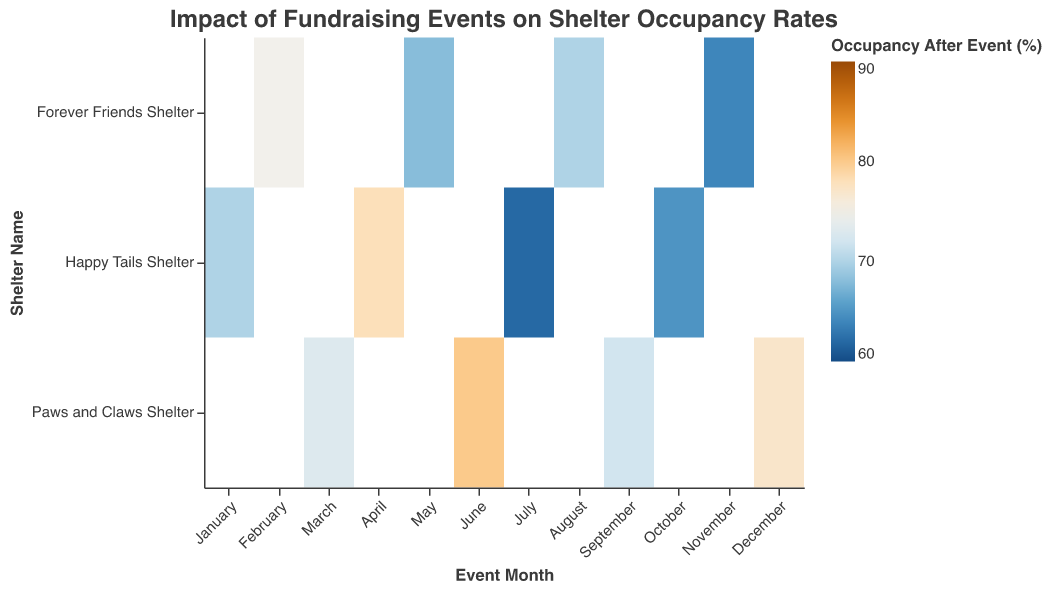What is the title of the figure? The title of the figure is displayed at the top of the heatmap. It is usually in a large font size and describes the main topic of the plot.
Answer: Impact of Fundraising Events on Shelter Occupancy Rates What are the axis labels in the heatmap? The axis labels describe what each axis represents. The x-axis is labeled "Event Month," and the y-axis is labeled "Shelter Name."
Answer: Event Month, Shelter Name Which event had the highest donation amount? By looking at the "Donation Amount (USD)" in the tooltip of each cell, the highest donation amount can be identified.
Answer: Gala Dinner in May Which shelter had the largest decrease in occupancy rate after an event? By comparing the "Occupancy Before Event (%)" and "Occupancy After Event (%)" values in each cell, the largest decrease can be identified. The largest decrease is for "Happy Tails Shelter" in July (88% - 62% = 26%).
Answer: Happy Tails Shelter in July What is the average post-event occupancy rate for Happy Tails Shelter? Adding the "Occupancy After Event (%)" values for Happy Tails Shelter's events and dividing by the number of events: (70 + 78 + 62 + 65) / 4 = 68.75%.
Answer: 68.75% Which event type appears most frequently in the heatmap? Counting the occurrences of each "Event Type" in the tooltip reveals that there are multiple events types, but several types have the same frequency. For example, "Auction" appears twice.
Answer: Auction Which month had the highest number of animals adopted? Summing the "Animals Adopted" for each event in each month, the month of May has the highest number of animals adopted with 25 adoptions.
Answer: May How does the post-event occupancy rate of "Paws and Claws Shelter" events vary by month? Checking the "Occupancy After Event (%)" for "Paws and Claws Shelter" events by month, the values are: March (73%), June (80%), September (72%), December (77%).
Answer: March (73%), June (80%), September (72%), December (77%) Which shelter had the highest occupancy rate before any event? By examining the "Occupancy Before Event (%)" values, "Forever Friends Shelter" in May had the highest pre-event occupancy rate of 92%.
Answer: Forever Friends Shelter in May Is there a correlation between donation amount and animals adopted? By visually comparing the "Donation Amount (USD)" and "Animals Adopted" in the tooltip of each cell, a general trend is noticeable that higher donations often correspond to more adoptions, but not always directly proportional.
Answer: There's a general positive correlation 